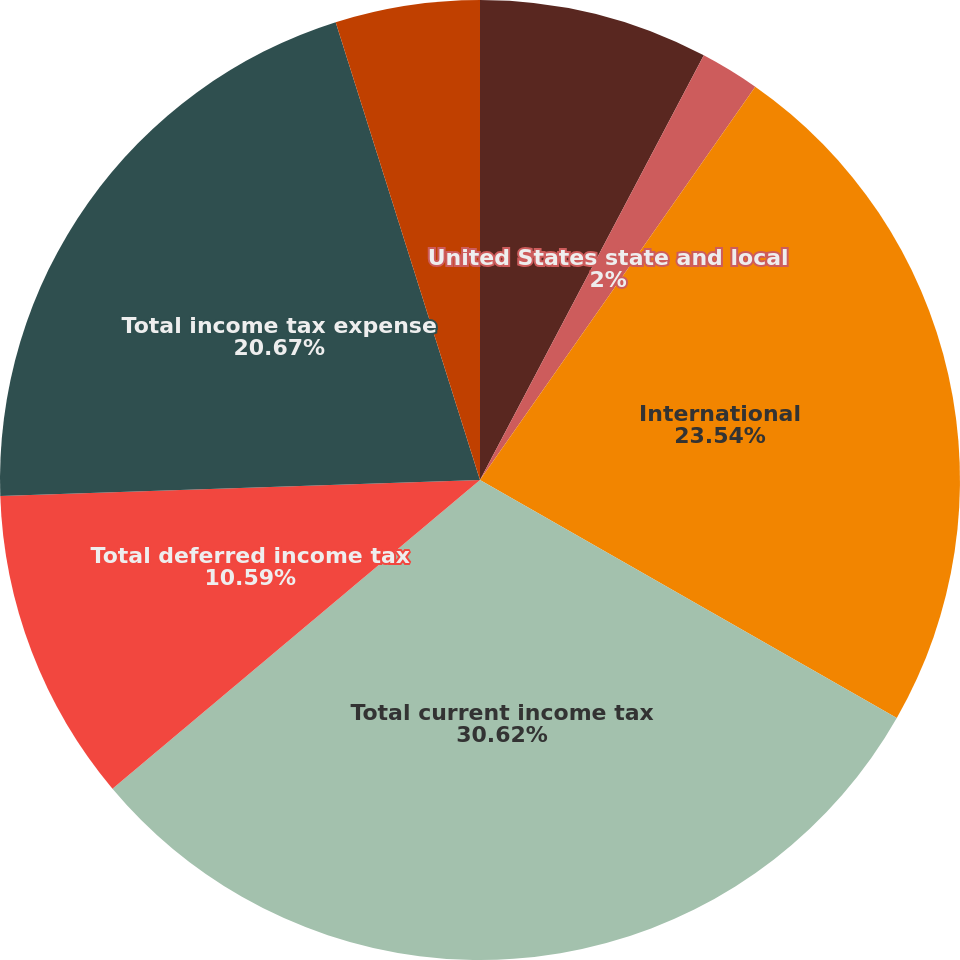Convert chart. <chart><loc_0><loc_0><loc_500><loc_500><pie_chart><fcel>United States federal<fcel>United States state and local<fcel>International<fcel>Total current income tax<fcel>Total deferred income tax<fcel>Total income tax expense<fcel>Interest expense and penalties<nl><fcel>7.72%<fcel>2.0%<fcel>23.54%<fcel>30.62%<fcel>10.59%<fcel>20.67%<fcel>4.86%<nl></chart> 